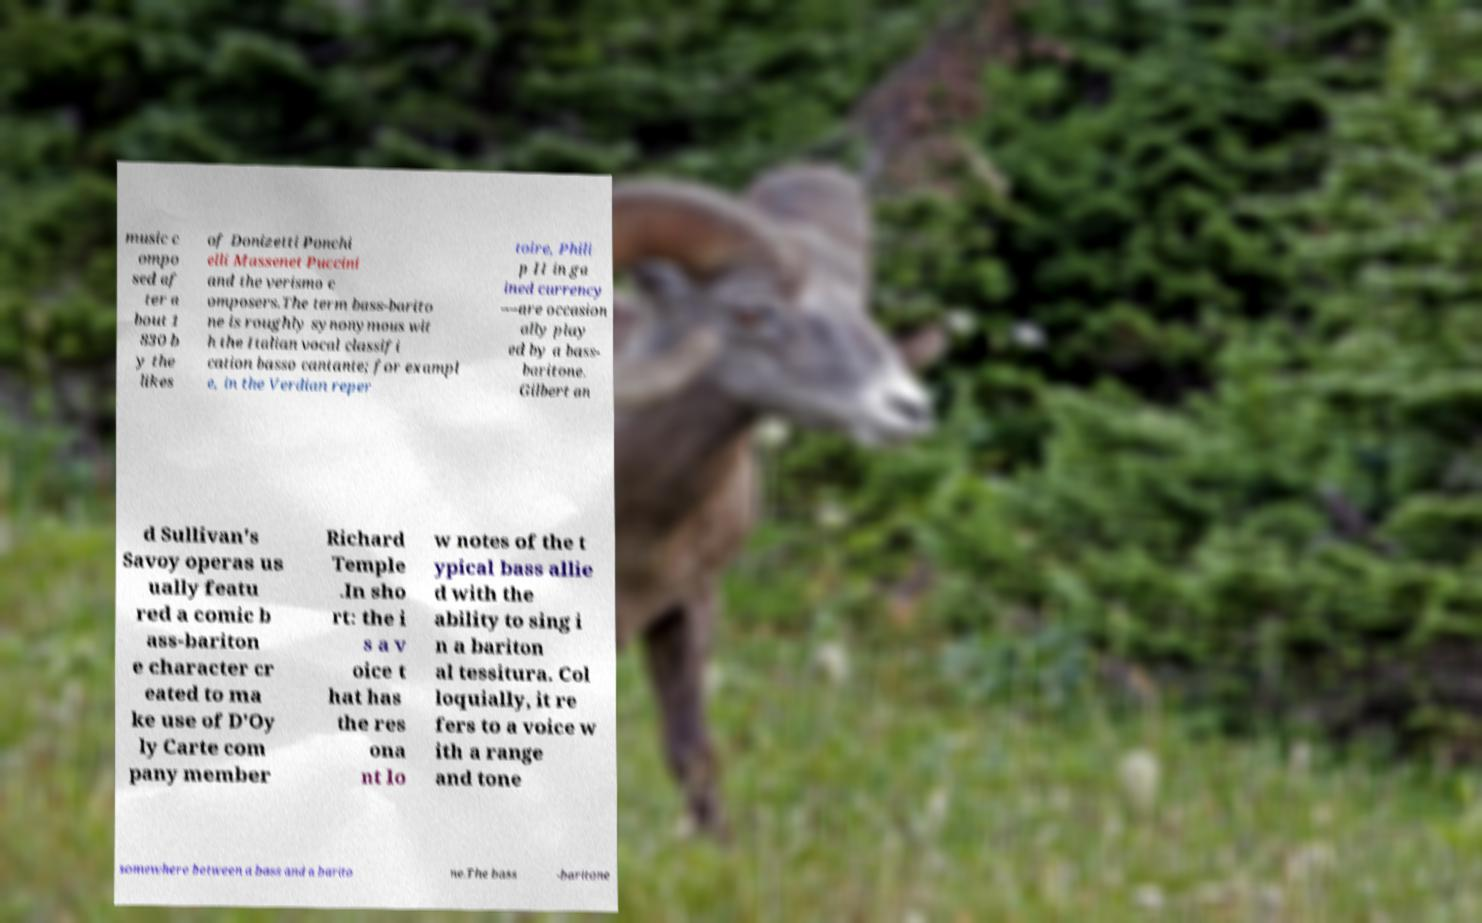Please identify and transcribe the text found in this image. music c ompo sed af ter a bout 1 830 b y the likes of Donizetti Ponchi elli Massenet Puccini and the verismo c omposers.The term bass-barito ne is roughly synonymous wit h the Italian vocal classifi cation basso cantante; for exampl e, in the Verdian reper toire, Phili p II in ga ined currency —are occasion ally play ed by a bass- baritone. Gilbert an d Sullivan's Savoy operas us ually featu red a comic b ass-bariton e character cr eated to ma ke use of D'Oy ly Carte com pany member Richard Temple .In sho rt: the i s a v oice t hat has the res ona nt lo w notes of the t ypical bass allie d with the ability to sing i n a bariton al tessitura. Col loquially, it re fers to a voice w ith a range and tone somewhere between a bass and a barito ne.The bass -baritone 